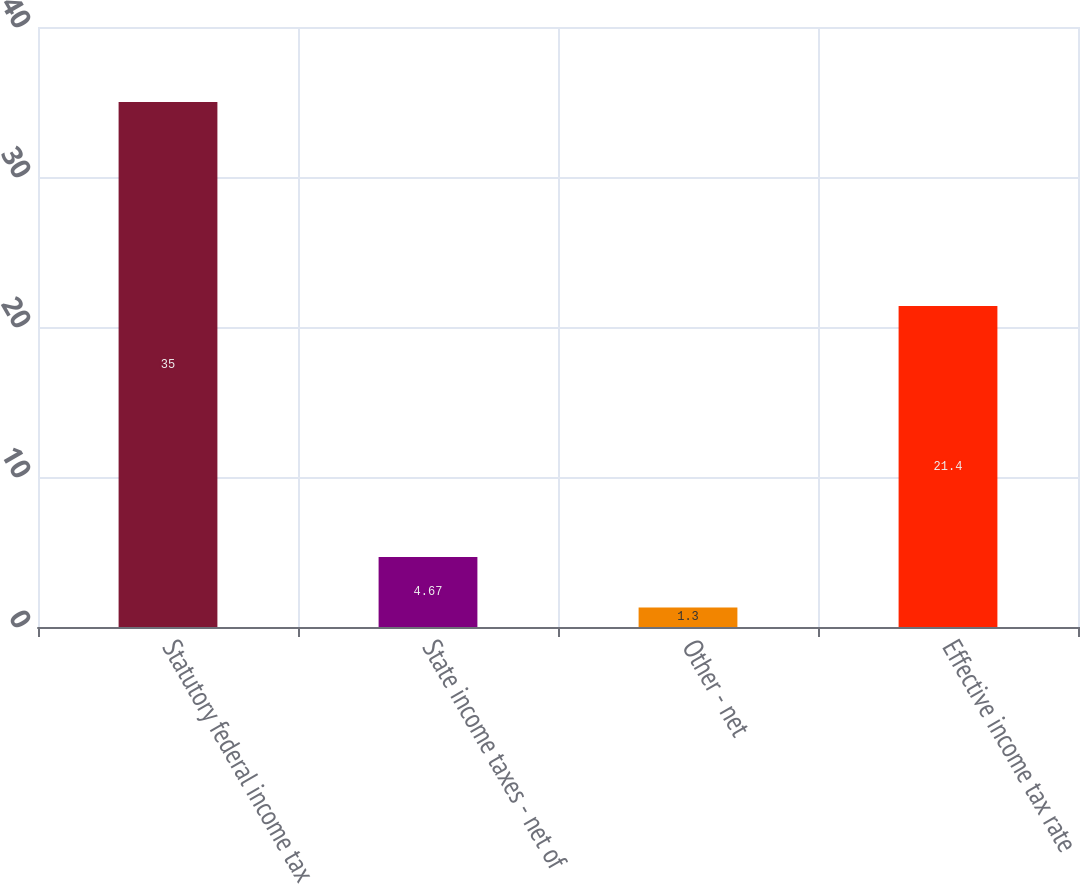Convert chart. <chart><loc_0><loc_0><loc_500><loc_500><bar_chart><fcel>Statutory federal income tax<fcel>State income taxes - net of<fcel>Other - net<fcel>Effective income tax rate<nl><fcel>35<fcel>4.67<fcel>1.3<fcel>21.4<nl></chart> 